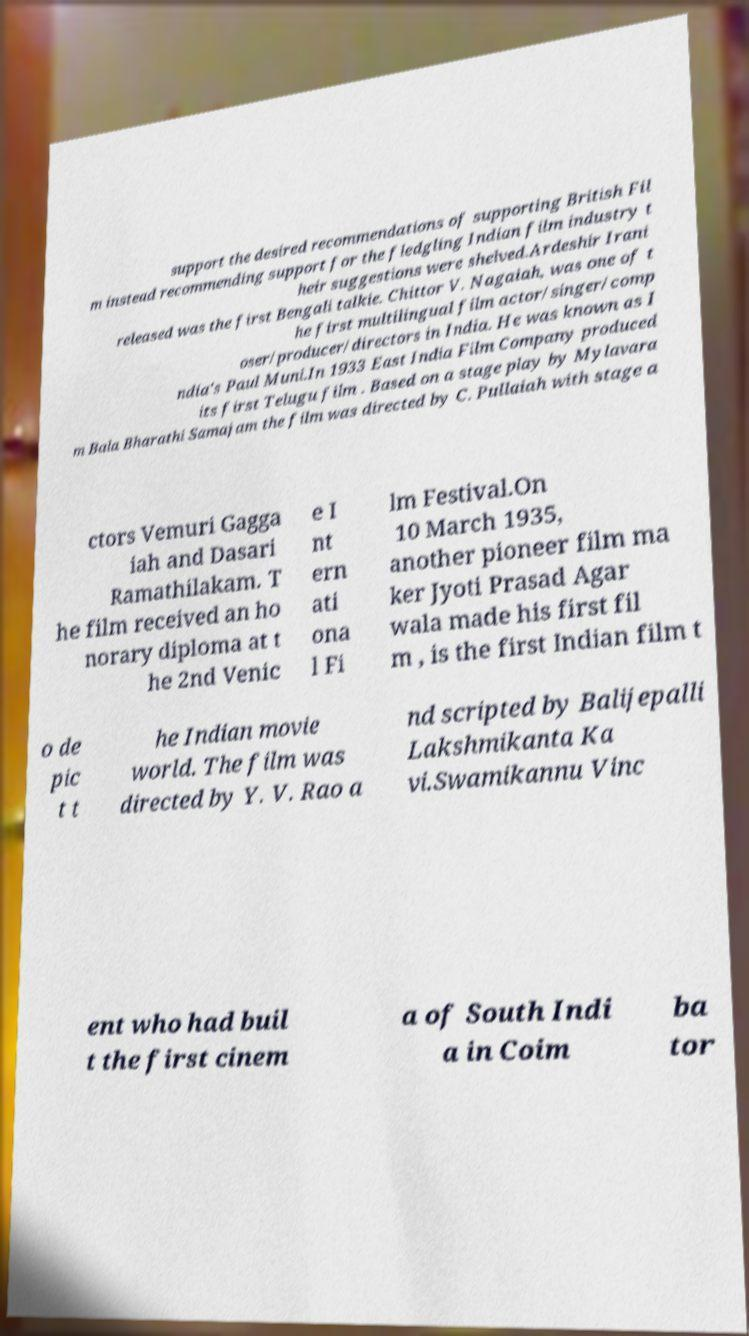For documentation purposes, I need the text within this image transcribed. Could you provide that? support the desired recommendations of supporting British Fil m instead recommending support for the fledgling Indian film industry t heir suggestions were shelved.Ardeshir Irani released was the first Bengali talkie. Chittor V. Nagaiah, was one of t he first multilingual film actor/singer/comp oser/producer/directors in India. He was known as I ndia's Paul Muni.In 1933 East India Film Company produced its first Telugu film . Based on a stage play by Mylavara m Bala Bharathi Samajam the film was directed by C. Pullaiah with stage a ctors Vemuri Gagga iah and Dasari Ramathilakam. T he film received an ho norary diploma at t he 2nd Venic e I nt ern ati ona l Fi lm Festival.On 10 March 1935, another pioneer film ma ker Jyoti Prasad Agar wala made his first fil m , is the first Indian film t o de pic t t he Indian movie world. The film was directed by Y. V. Rao a nd scripted by Balijepalli Lakshmikanta Ka vi.Swamikannu Vinc ent who had buil t the first cinem a of South Indi a in Coim ba tor 